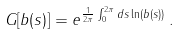<formula> <loc_0><loc_0><loc_500><loc_500>G [ b ( s ) ] = e ^ { \frac { 1 } { 2 \pi } \int _ { 0 } ^ { 2 \pi } d s \ln ( b ( s ) ) } \, .</formula> 